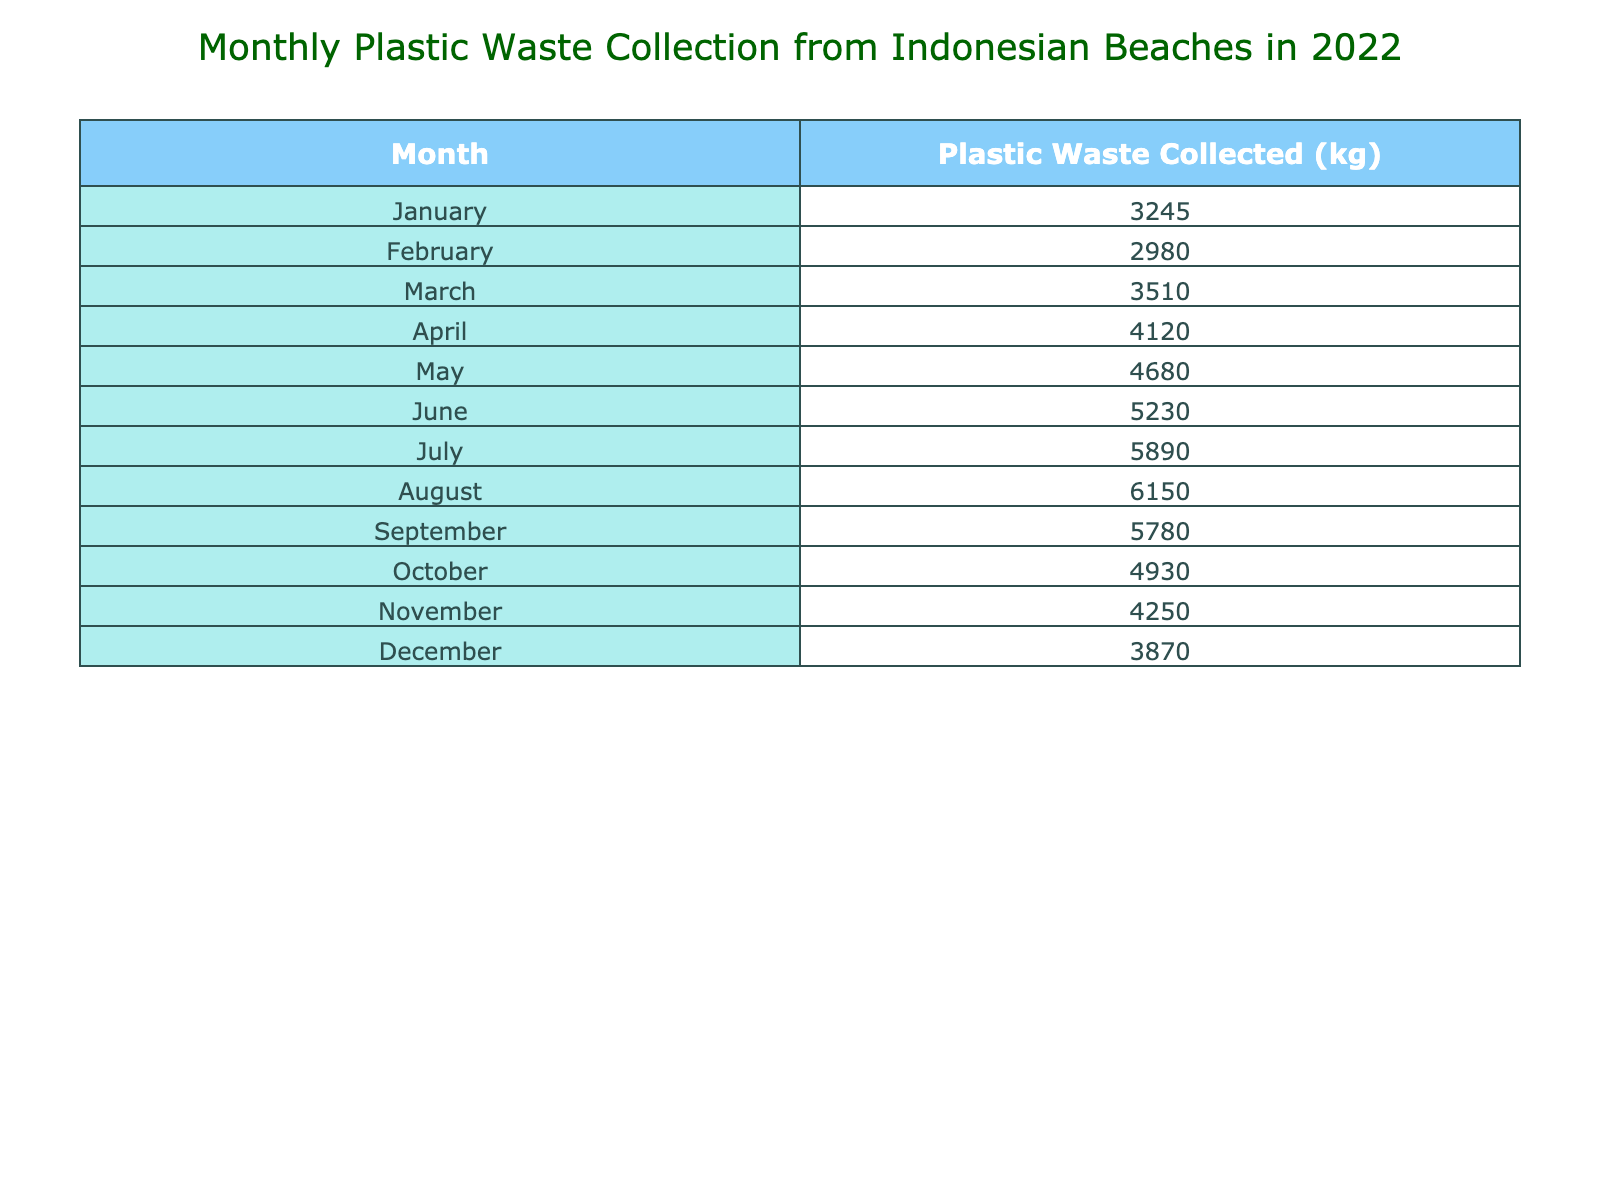What's the total amount of plastic waste collected in June? The value for June in the table is 5230 kg, so the total amount of plastic waste collected in June is 5230 kg.
Answer: 5230 kg Which month saw the highest plastic waste collection? August shows the highest collection with 6150 kg, making it the month with the most plastic waste collected.
Answer: August What is the difference in plastic waste collected between July and December? The value for July is 5890 kg and for December is 3870 kg. The difference is 5890 - 3870 = 2020 kg.
Answer: 2020 kg How much plastic waste was collected in the first half of 2022 compared to the second half? The total for the first half (January to June) is 3245 + 2980 + 3510 + 4120 + 4680 + 5230 = 22815 kg. The second half (July to December) is 5890 + 6150 + 5780 + 4930 + 4250 + 3870 = 27470 kg. So, the second half collected 27470 - 22815 = 4645 kg more than the first half.
Answer: 4645 kg more in the second half What was the average plastic waste collected over the year? To find the average, sum all waste amounts (3245 + 2980 + 3510 + 4120 + 4680 + 5230 + 5890 + 6150 + 5780 + 4930 + 4250 + 3870 = 57715 kg) and divide by 12 months. 57715 / 12 = 4809.58 kg.
Answer: 4809.58 kg Was there a decrease in plastic waste collected from September to October? September collected 5780 kg and October collected 4930 kg. Since 4930 is less than 5780, there was indeed a decrease.
Answer: Yes Which two months had the least amount of plastic waste collected? November (4250 kg) and February (2980 kg) had the least waste, as they are the two lowest values in the table.
Answer: November and February 